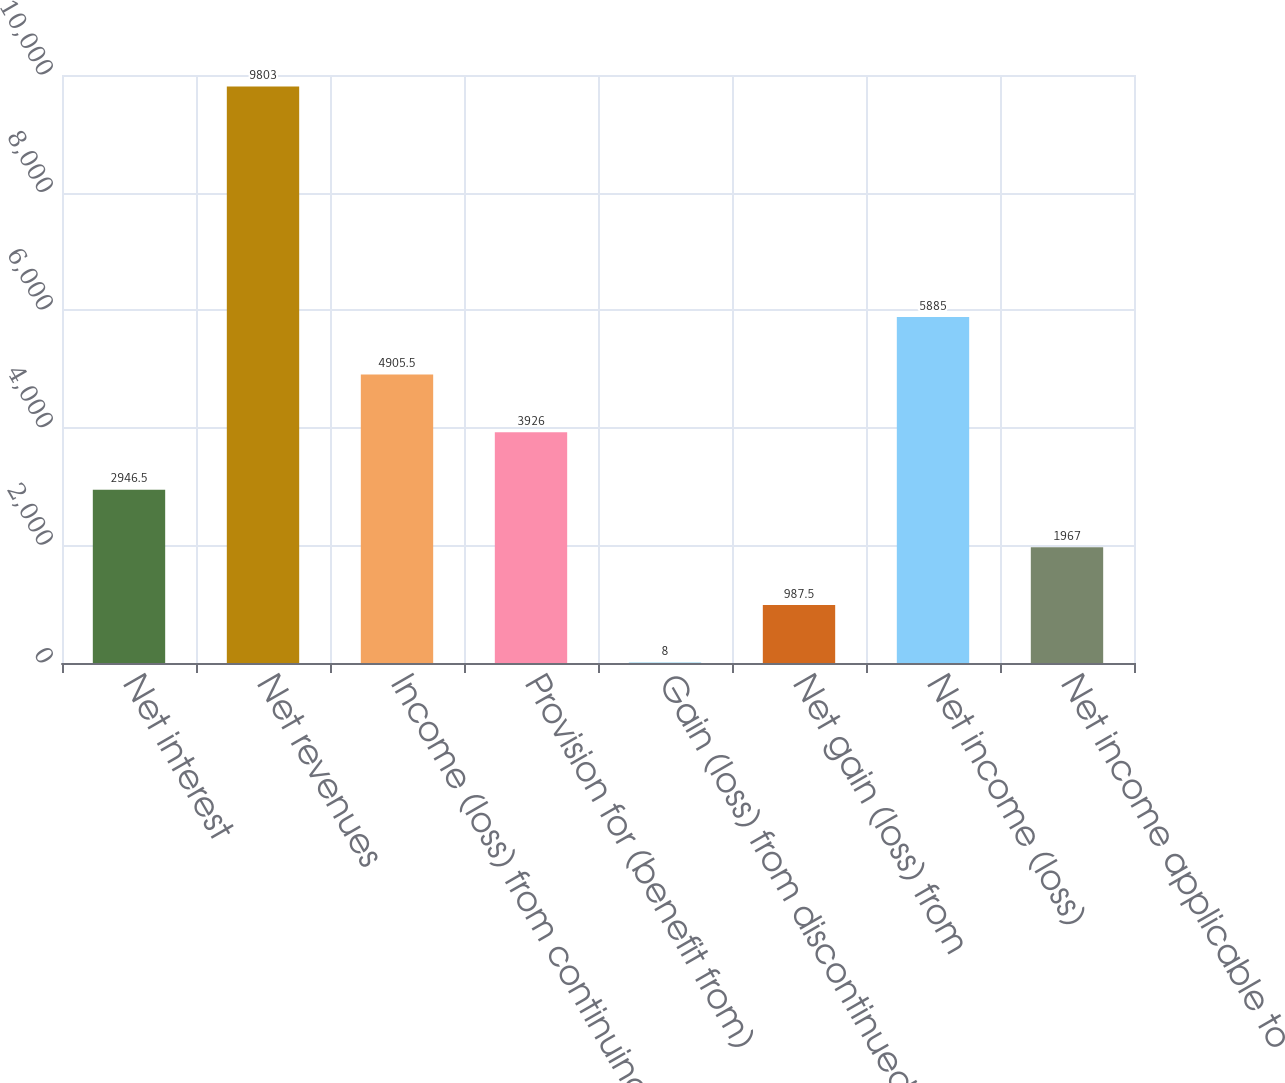<chart> <loc_0><loc_0><loc_500><loc_500><bar_chart><fcel>Net interest<fcel>Net revenues<fcel>Income (loss) from continuing<fcel>Provision for (benefit from)<fcel>Gain (loss) from discontinued<fcel>Net gain (loss) from<fcel>Net income (loss)<fcel>Net income applicable to<nl><fcel>2946.5<fcel>9803<fcel>4905.5<fcel>3926<fcel>8<fcel>987.5<fcel>5885<fcel>1967<nl></chart> 